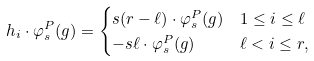<formula> <loc_0><loc_0><loc_500><loc_500>h _ { i } \cdot \varphi ^ { P } _ { s } ( g ) & = \begin{cases} s ( r - \ell ) \cdot \varphi _ { s } ^ { P } ( g ) & 1 \leq i \leq \ell \\ - s \ell \cdot \varphi ^ { P } _ { s } ( g ) & \ell < i \leq r , \end{cases}</formula> 